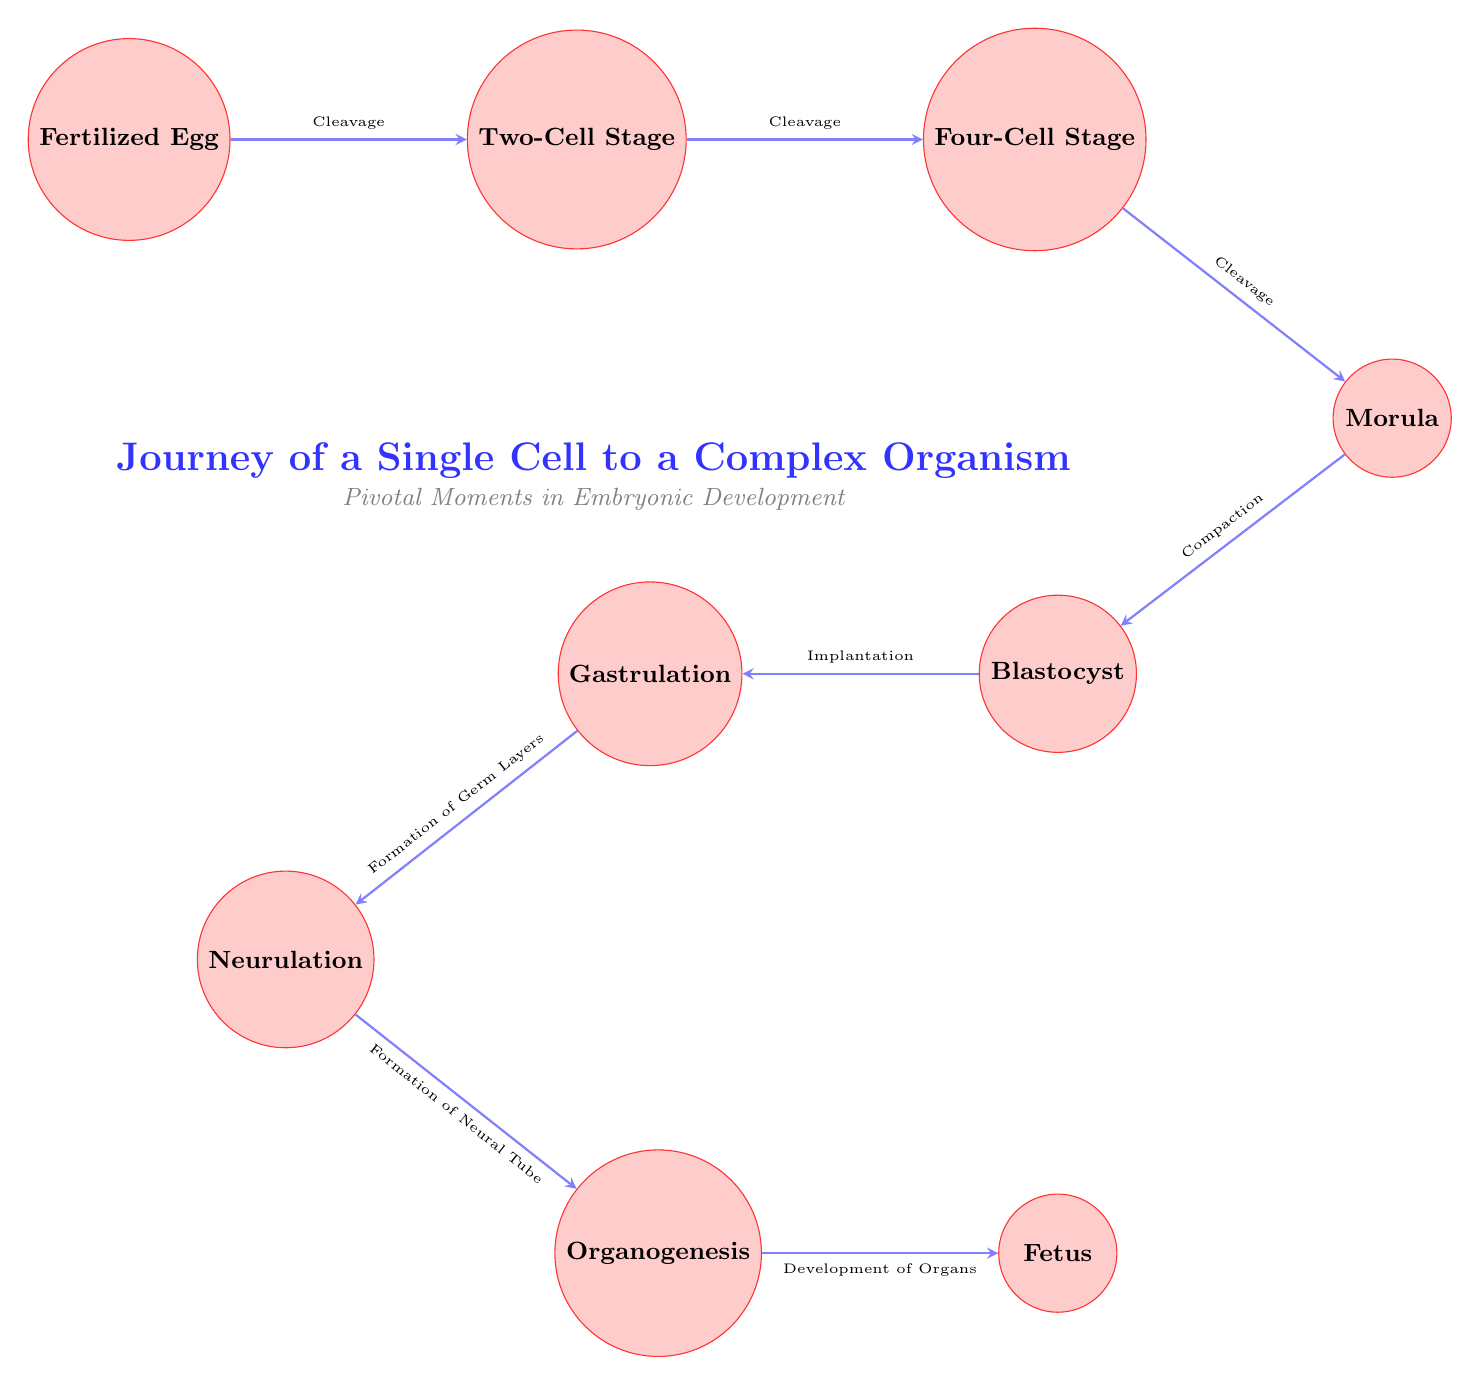What is the first stage of embryonic development? The diagram shows the first node labeled as "Fertilized Egg," indicating it is the initial stage of embryonic development.
Answer: Fertilized Egg What process occurs between the Four-Cell Stage and the Morula? The diagram indicates an arrow connecting the Four-Cell Stage to the Morula, with the label "Cleavage," suggesting that this is the process that happens during this transition.
Answer: Cleavage How many main stages are shown from the Fertilized Egg to the Fetus? By counting the nodes listed in the diagram, there are a total of eight distinct stages from "Fertilized Egg" to "Fetus," which includes all embryonic stages depicted.
Answer: 8 What stage follows Gastrulation? The diagram shows an arrow directed from the Gastrulation node to the Neurulation node, indicating that Neurulation is the stage that follows Gastrulation.
Answer: Neurulation Which process occurs during the transition from Blastocyst to Gastrulation? The diagram depicts an arrow leading from the Blastocyst to the Gastrulation node, labeled "Implantation," indicating that this process occurs during this transition.
Answer: Implantation What is the last developmental stage shown in the diagram? The final node on the right labeled "Fetus" indicates it is the ultimate stage of development presented in the diagram.
Answer: Fetus What connects the Morula to the Blastocyst? The diagram illustrates an arrow between these two stages, labeled "Compaction," indicating this is the connecting process between them.
Answer: Compaction What critical processes occur during Organogenesis? The diagram transitions from Organogenesis to the Fetus, indicating that "Development of Organs" is the process occurring in this stage, which is pivotal in the growth of the organism.
Answer: Development of Organs During which stage do the germ layers form? According to the diagram, the transition from Blastocyst to Gastrulation shows the label "Formation of Germ Layers," indicating this is the stage during which they form.
Answer: Gastrulation 